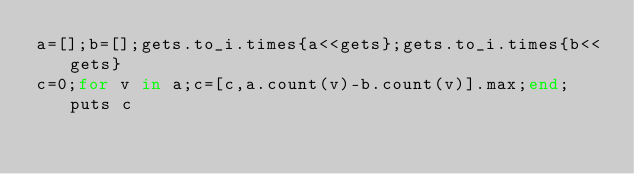<code> <loc_0><loc_0><loc_500><loc_500><_Ruby_>a=[];b=[];gets.to_i.times{a<<gets};gets.to_i.times{b<<gets}
c=0;for v in a;c=[c,a.count(v)-b.count(v)].max;end;puts c</code> 